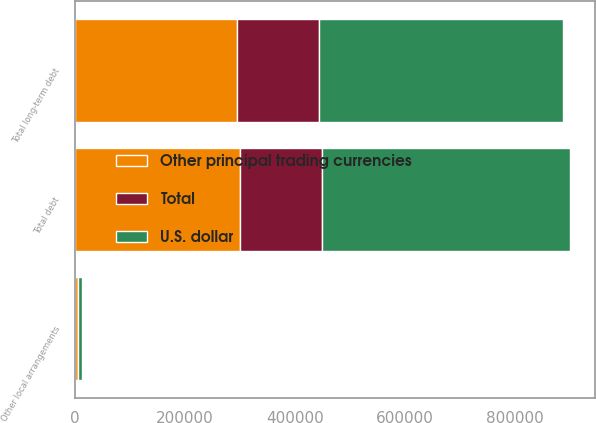Convert chart. <chart><loc_0><loc_0><loc_500><loc_500><stacked_bar_chart><ecel><fcel>Total long-term debt<fcel>Other local arrangements<fcel>Total debt<nl><fcel>Total<fcel>149468<fcel>107<fcel>149575<nl><fcel>Other principal trading currencies<fcel>294327<fcel>6238<fcel>300565<nl><fcel>U.S. dollar<fcel>443795<fcel>6345<fcel>450140<nl></chart> 